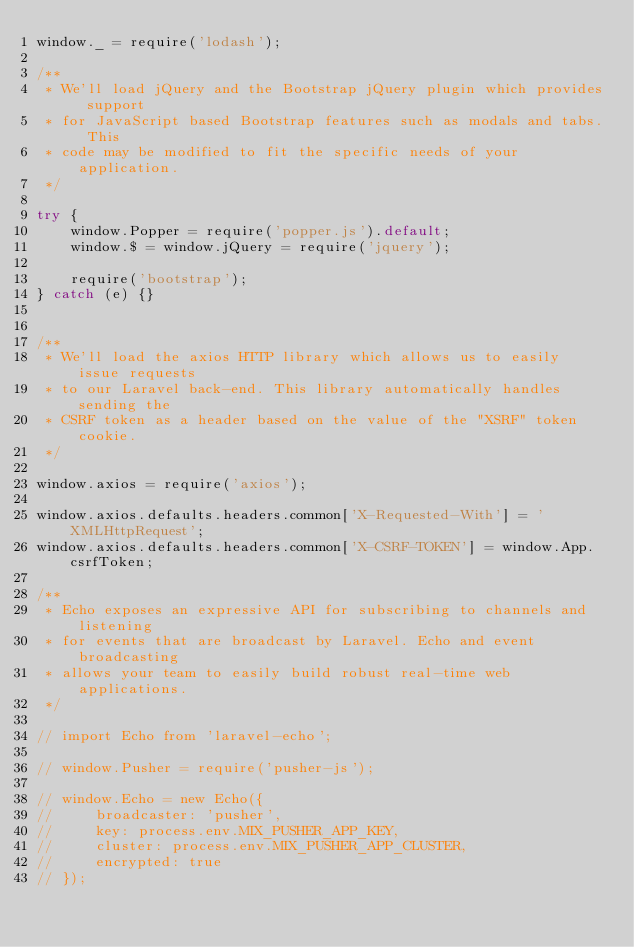Convert code to text. <code><loc_0><loc_0><loc_500><loc_500><_JavaScript_>window._ = require('lodash');

/**
 * We'll load jQuery and the Bootstrap jQuery plugin which provides support
 * for JavaScript based Bootstrap features such as modals and tabs. This
 * code may be modified to fit the specific needs of your application.
 */

try {
    window.Popper = require('popper.js').default;
    window.$ = window.jQuery = require('jquery');

    require('bootstrap');
} catch (e) {}


/**
 * We'll load the axios HTTP library which allows us to easily issue requests
 * to our Laravel back-end. This library automatically handles sending the
 * CSRF token as a header based on the value of the "XSRF" token cookie.
 */

window.axios = require('axios');

window.axios.defaults.headers.common['X-Requested-With'] = 'XMLHttpRequest';
window.axios.defaults.headers.common['X-CSRF-TOKEN'] = window.App.csrfToken;

/**
 * Echo exposes an expressive API for subscribing to channels and listening
 * for events that are broadcast by Laravel. Echo and event broadcasting
 * allows your team to easily build robust real-time web applications.
 */

// import Echo from 'laravel-echo';

// window.Pusher = require('pusher-js');

// window.Echo = new Echo({
//     broadcaster: 'pusher',
//     key: process.env.MIX_PUSHER_APP_KEY,
//     cluster: process.env.MIX_PUSHER_APP_CLUSTER,
//     encrypted: true
// });</code> 